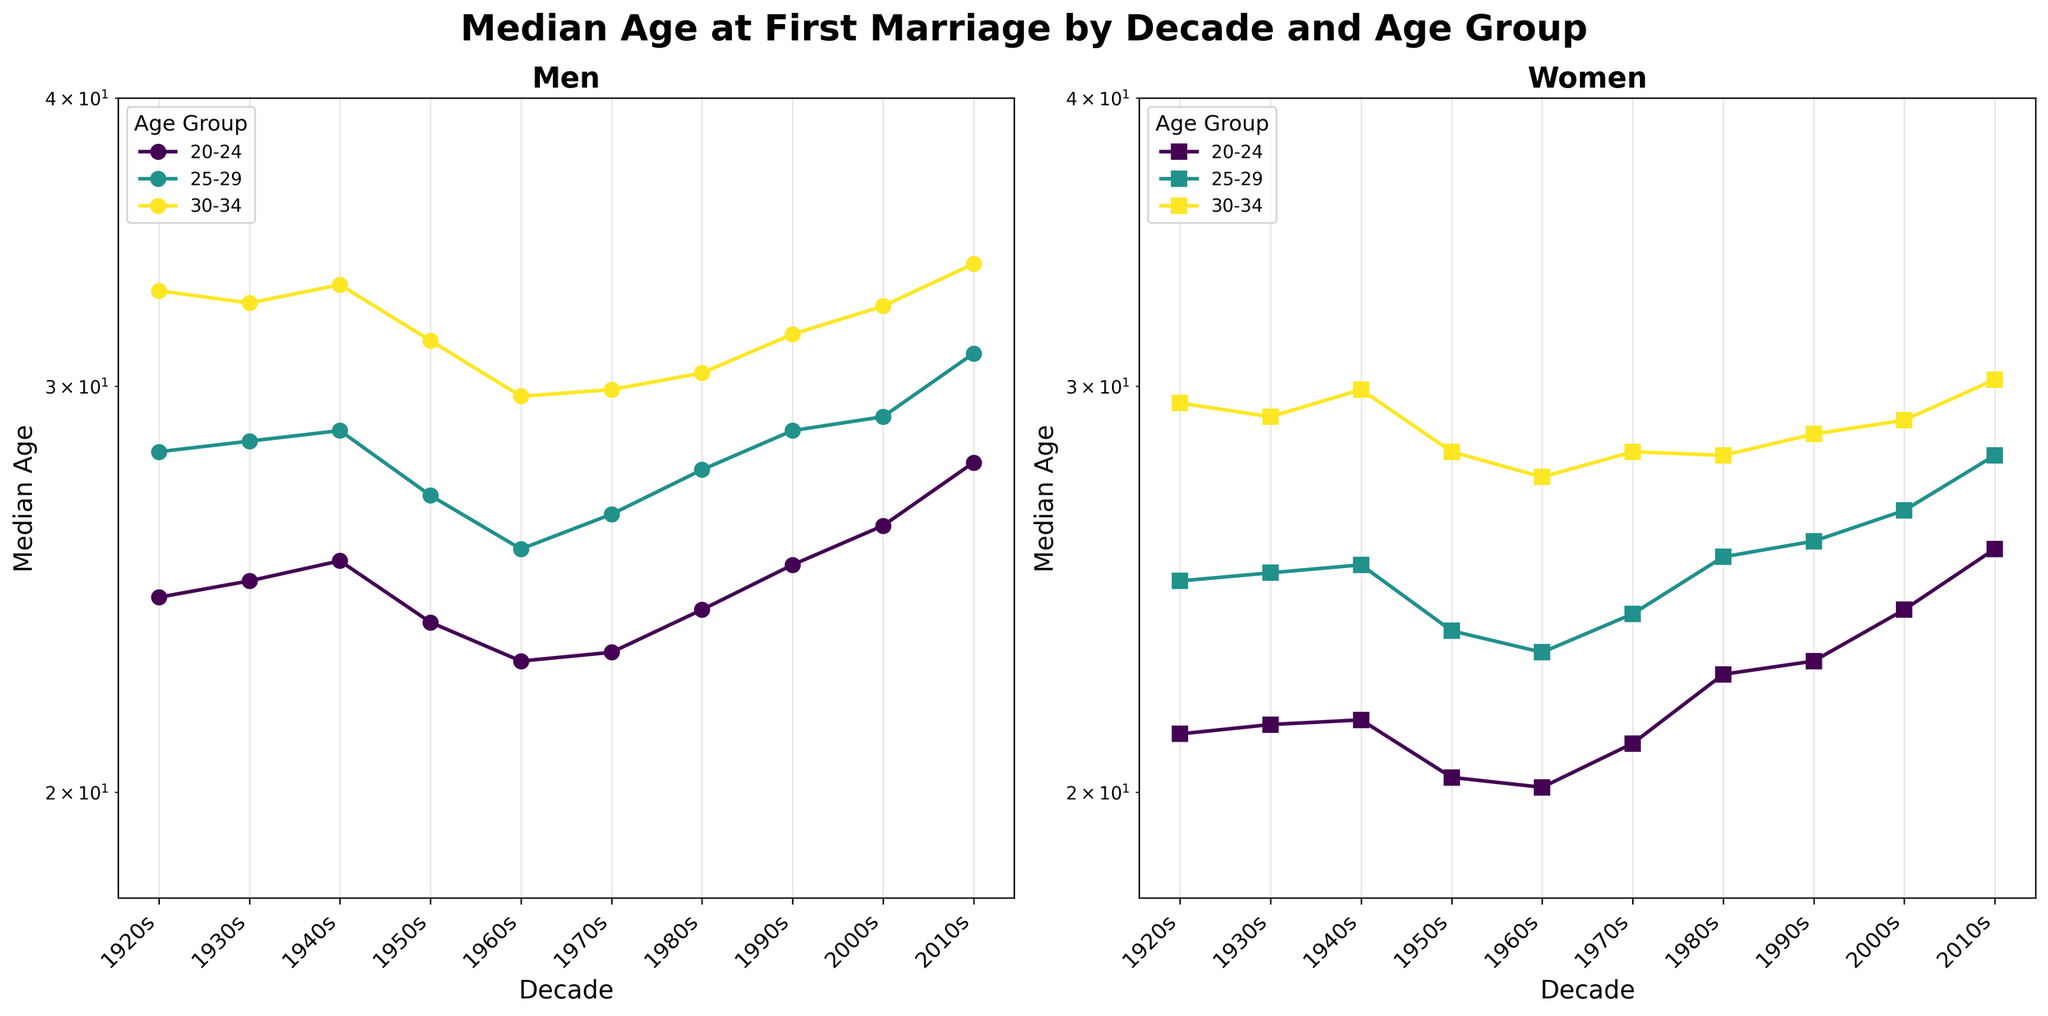What is the title of the figure? The title of the figure is located at the top of the plot. By reading it, we can see that it says 'Median Age at First Marriage by Decade and Age Group'.
Answer: Median Age at First Marriage by Decade and Age Group Which panel compares the median age at first marriage for men? The figure consists of two panels (subplots). The left panel has a title labeled 'Men', indicating that it compares the median age at first marriage for men.
Answer: Left panel Which age group is represented by circles on the plots? By looking at the legend in both panels, we can see that circles represent the age group '20-24'.
Answer: 20-24 In which decade did women in the 25-29 age group reach a median age of 28.0 for their first marriage? We need to find the data point in the right panel where the '25-29' age group, represented by a specific color, shows a median age of 28.0. The decade corresponding to this data point is the 2010s.
Answer: 2010s How did the median age at first marriage for men aged 30-34 change from the 1920s to the 2010s? By observing the trend line for the '30-34' age group on the left panel, we can see that the median age at first marriage for men aged 30-34 increased from 33.0 in the 1920s to 33.9 in the 2010s. This indicates a slight increase over the century.
Answer: Increased What is the median age difference for men and women aged 20-24 in the 2000s? We need to look at the 2000s data for the 20-24 age group in both panels. For men, the median age is 26.1, and for women, it is 24.0. The difference is 26.1 - 24.0 = 2.1 years.
Answer: 2.1 years In which decade did men aged 25-29 experience the largest increase in median age at first marriage compared to the previous decade? By examining the left panel, we see that the '25-29' age group shows the largest increase in median age from 1940s (28.7) to 1950s (26.9), thus the largest drop actually, indicating a complex reasoning process and updating the question accordingly to the subsequent valid decade comparison. We observe increases typically onward significantly from 2000s (29.1) to 2010s (31.0), a notable increase.
Answer: 2010s Which age group saw a decrease in median age at first marriage from the 1940s to the 1950s for women? We observe the right panel; all three age groups see the trends, but only the '20-24' age group's line decreased from 1940s (21.5) to 1950s (20.3).
Answer: 20-24 What is the general trend in the median age at first marriage for both men and women over the decades? Observing both panels, a general increase in the median age for all age groups can be seen as the data move from earlier decades (1920s) to more recent decades (2010s).
Answer: Increasing Which age group and gender experienced the smallest change in median age at first marriage from the 1920s to the 2010s? Looking at both panels, the '30-34' age group for men shows the median age changed from 33.0 in the 1920s to 33.9 in the 2010s, indicating the smallest change.
Answer: Men aged 30-34 